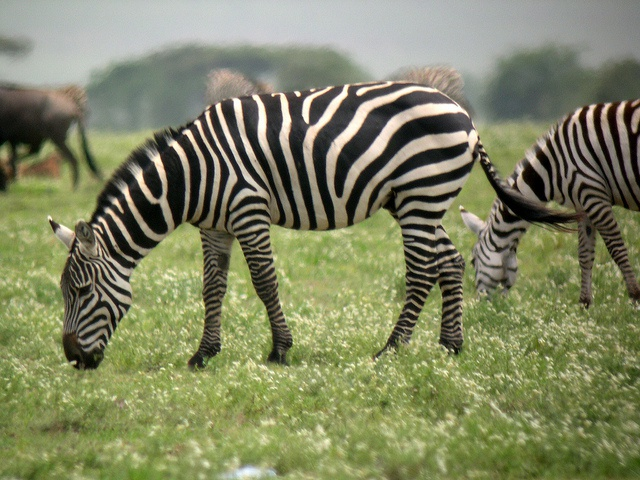Describe the objects in this image and their specific colors. I can see zebra in darkgray, black, and gray tones, zebra in darkgray, black, gray, and darkgreen tones, zebra in darkgray, gray, and tan tones, and zebra in darkgray and gray tones in this image. 